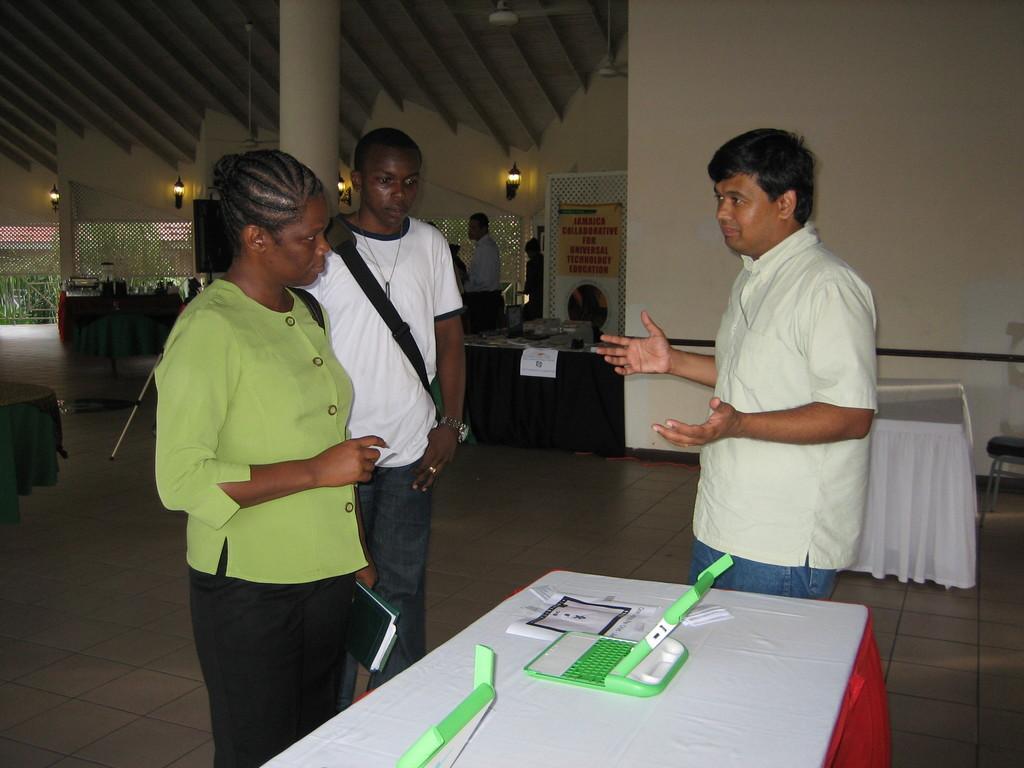Could you give a brief overview of what you see in this image? This image is clicked inside a room. There are a few people standing. There are many tables. There are clothes spread on the tables. In the foreground there is a table. On the table there are papers and gadgets. Beside the table there are three people standing. Behind them there is a pillar. In the background there is a wall. There are lambs to the wall. Outside the room there are plants and another house. 